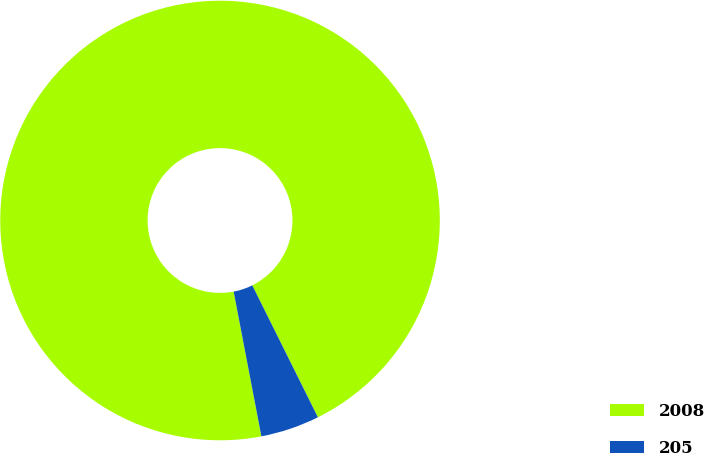<chart> <loc_0><loc_0><loc_500><loc_500><pie_chart><fcel>2008<fcel>205<nl><fcel>95.67%<fcel>4.33%<nl></chart> 